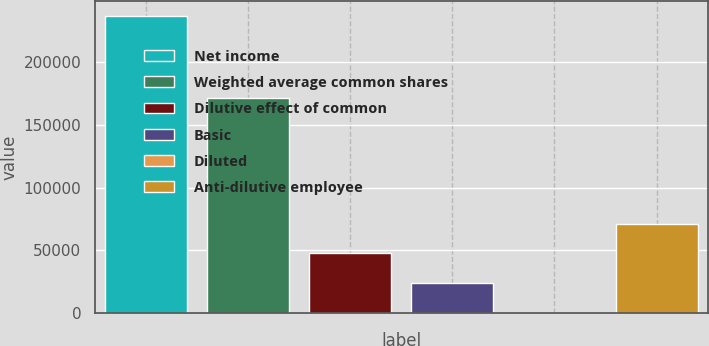<chart> <loc_0><loc_0><loc_500><loc_500><bar_chart><fcel>Net income<fcel>Weighted average common shares<fcel>Dilutive effect of common<fcel>Basic<fcel>Diluted<fcel>Anti-dilutive employee<nl><fcel>237063<fcel>171719<fcel>47413.8<fcel>23707.7<fcel>1.56<fcel>71120<nl></chart> 